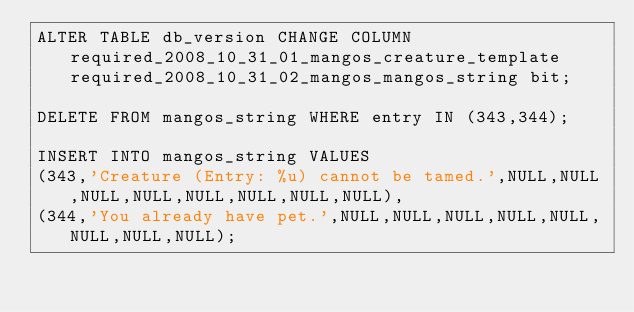Convert code to text. <code><loc_0><loc_0><loc_500><loc_500><_SQL_>ALTER TABLE db_version CHANGE COLUMN required_2008_10_31_01_mangos_creature_template required_2008_10_31_02_mangos_mangos_string bit;

DELETE FROM mangos_string WHERE entry IN (343,344);

INSERT INTO mangos_string VALUES
(343,'Creature (Entry: %u) cannot be tamed.',NULL,NULL,NULL,NULL,NULL,NULL,NULL,NULL),
(344,'You already have pet.',NULL,NULL,NULL,NULL,NULL,NULL,NULL,NULL);
</code> 